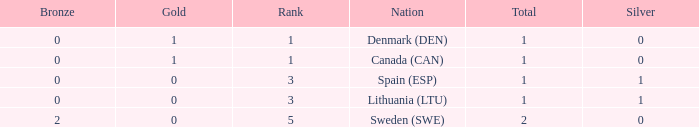How many bronze medals were won when the total is more than 1, and gold is more than 0? None. 